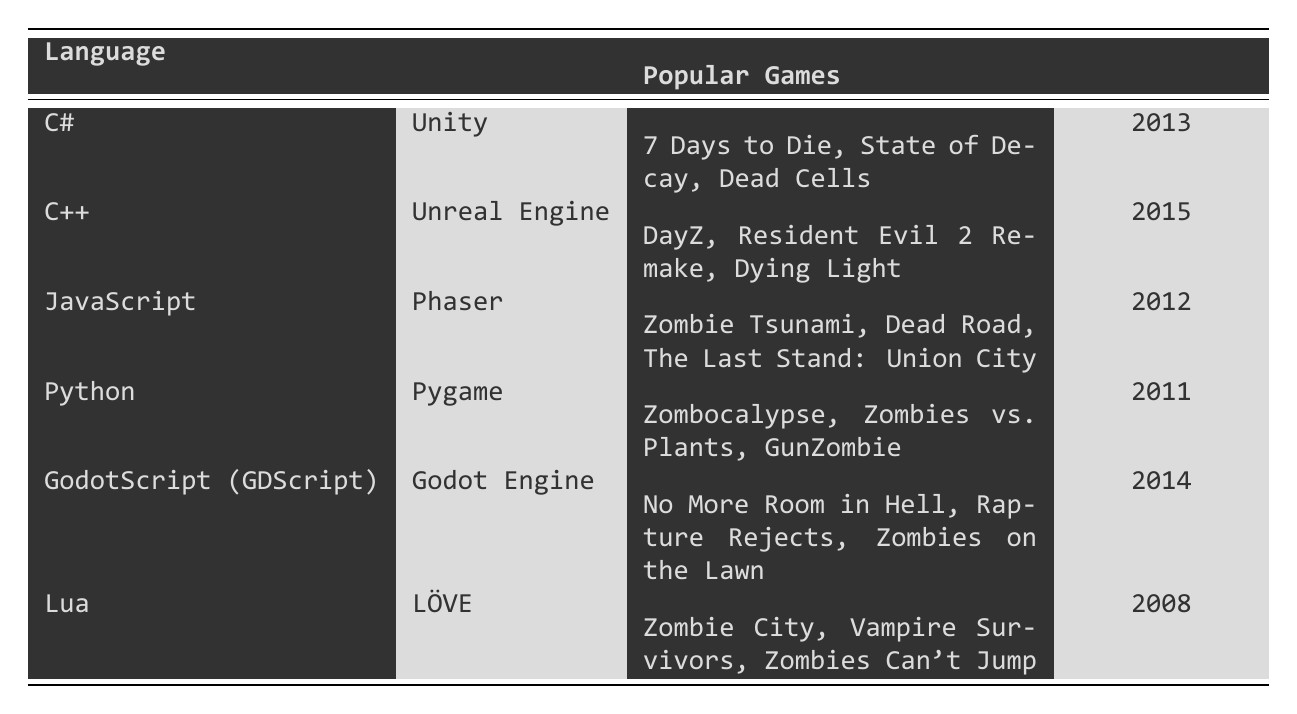What coding language is associated with the Unity engine? From the table, we can see that C# is listed as the coding language used with the Unity engine.
Answer: C# Which game released in 2015 uses C++? According to the table, the game "Dying Light" was released in 2015 and uses the C++ language.
Answer: Dying Light How many popular games are listed for Python? In the table, there are three games listed under Python: "Zombocalypse," "Zombies vs. Plants," and "GunZombie." Therefore, the count is three.
Answer: 3 Was "Zombie City" developed using Godot Engine? The table lists "Zombie City" as a game developed using LÖVE and not associated with the Godot Engine; thus, the answer is false.
Answer: No Which coding language has the oldest popular game listed? The oldest release year under the popular games is 2008, corresponding to Lua with the game "Zombie City." Thus, Lua is the coding language with the oldest popular game.
Answer: Lua List the engines associated with the games released after 2013. From the table, the engines used after 2013 are Unreal Engine (C++), Godot Engine (GDScript), and Unity (C#).
Answer: Unreal Engine, Godot Engine, Unity What is the total number of popular games listed for all languages? By counting the popular games listed under each coding language: 3 (C#) + 3 (C++) + 3 (JavaScript) + 3 (Python) + 3 (GodotScript) + 3 (Lua) = 18. The total is 18 popular games.
Answer: 18 Identify the coding language used for the game "Zombies Can't Jump." The game "Zombies Can't Jump" is listed under Lua in the table, indicating that Lua is the coding language used for this game.
Answer: Lua Which game has the latest release year and what is that year? The latest release year in the table is 2015, associated with the game "Dying Light."
Answer: 2015, Dying Light How many games are associated with the Phaser engine? The table shows that there are three games listed under the Phaser engine: "Zombie Tsunami," "Dead Road," and "The Last Stand: Union City."
Answer: 3 Is Python used with the Unreal Engine? The table does not list Python as a language used with the Unreal Engine; it is listed with Pygame instead. Thus, this statement is false.
Answer: No 